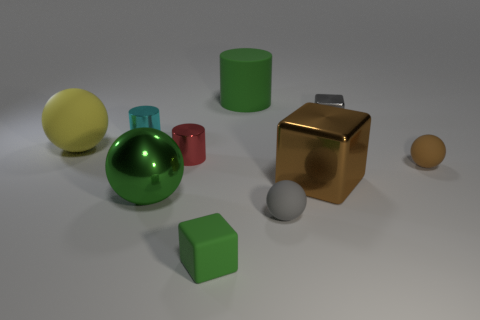The large metal thing in front of the large brown shiny block has what shape?
Make the answer very short. Sphere. The cylinder that is made of the same material as the yellow object is what size?
Offer a very short reply. Large. What number of other yellow things are the same shape as the large yellow thing?
Keep it short and to the point. 0. There is a rubber ball that is to the right of the large metallic block; does it have the same color as the large cube?
Offer a very short reply. Yes. There is a small block in front of the gray object behind the small cyan shiny thing; what number of gray spheres are to the right of it?
Offer a terse response. 1. How many large things are both behind the tiny red metallic cylinder and in front of the small cyan metal thing?
Make the answer very short. 1. What shape is the large matte object that is the same color as the shiny ball?
Offer a very short reply. Cylinder. Is the material of the big yellow object the same as the brown block?
Ensure brevity in your answer.  No. There is a tiny gray object behind the rubber sphere that is on the right side of the large brown block right of the small red metallic cylinder; what shape is it?
Provide a succinct answer. Cube. Is the number of small green rubber things on the left side of the green rubber cylinder less than the number of rubber objects behind the gray metallic cube?
Offer a terse response. No. 